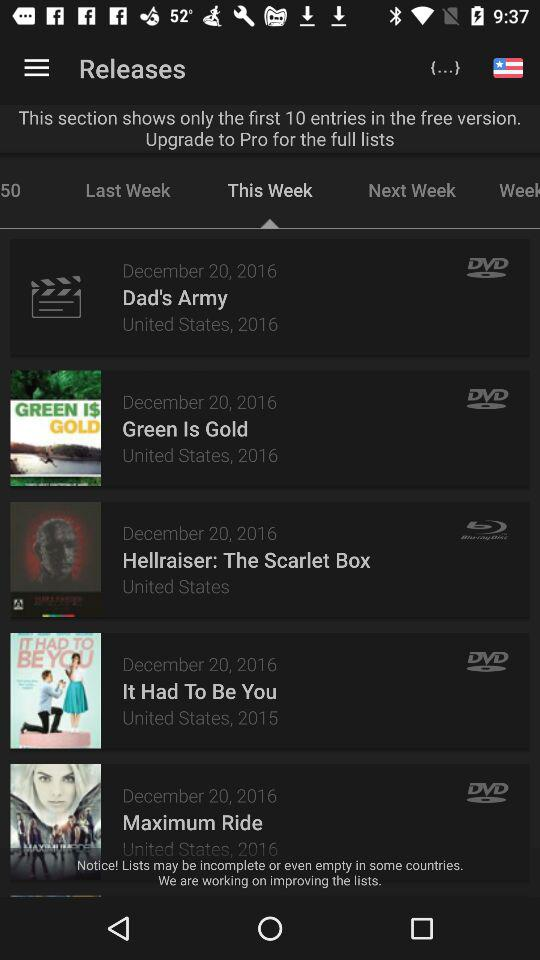What's the Total Number of Movie in the list of Free version?
When the provided information is insufficient, respond with <no answer>. <no answer> 